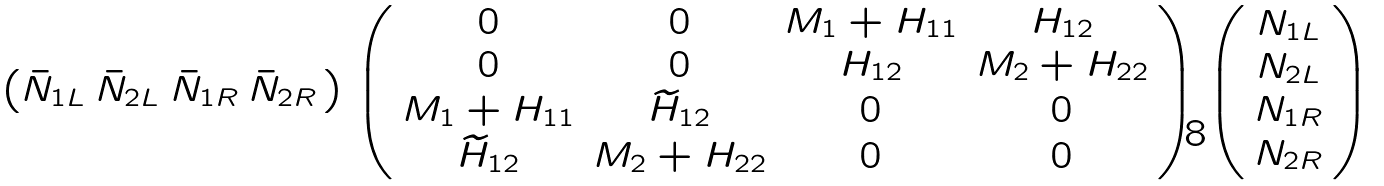Convert formula to latex. <formula><loc_0><loc_0><loc_500><loc_500>\left ( \bar { N } _ { 1 L } \, \bar { N } _ { 2 L } \, \bar { N } _ { 1 R } \, \bar { N } _ { 2 R } \, \right ) \left ( \begin{array} { c c c c c c } 0 & 0 & M _ { 1 } + H _ { 1 1 } & H _ { 1 2 } \\ 0 & 0 & H _ { 1 2 } & M _ { 2 } + H _ { 2 2 } \\ M _ { 1 } + H _ { 1 1 } & \widetilde { H } _ { 1 2 } & 0 & 0 \\ \widetilde { H } _ { 1 2 } & M _ { 2 } + H _ { 2 2 } & 0 & 0 \\ \end{array} \right ) \left ( \begin{array} { c } N _ { 1 L } \\ N _ { 2 L } \\ N _ { 1 R } \\ N _ { 2 R } \\ \end{array} \right )</formula> 